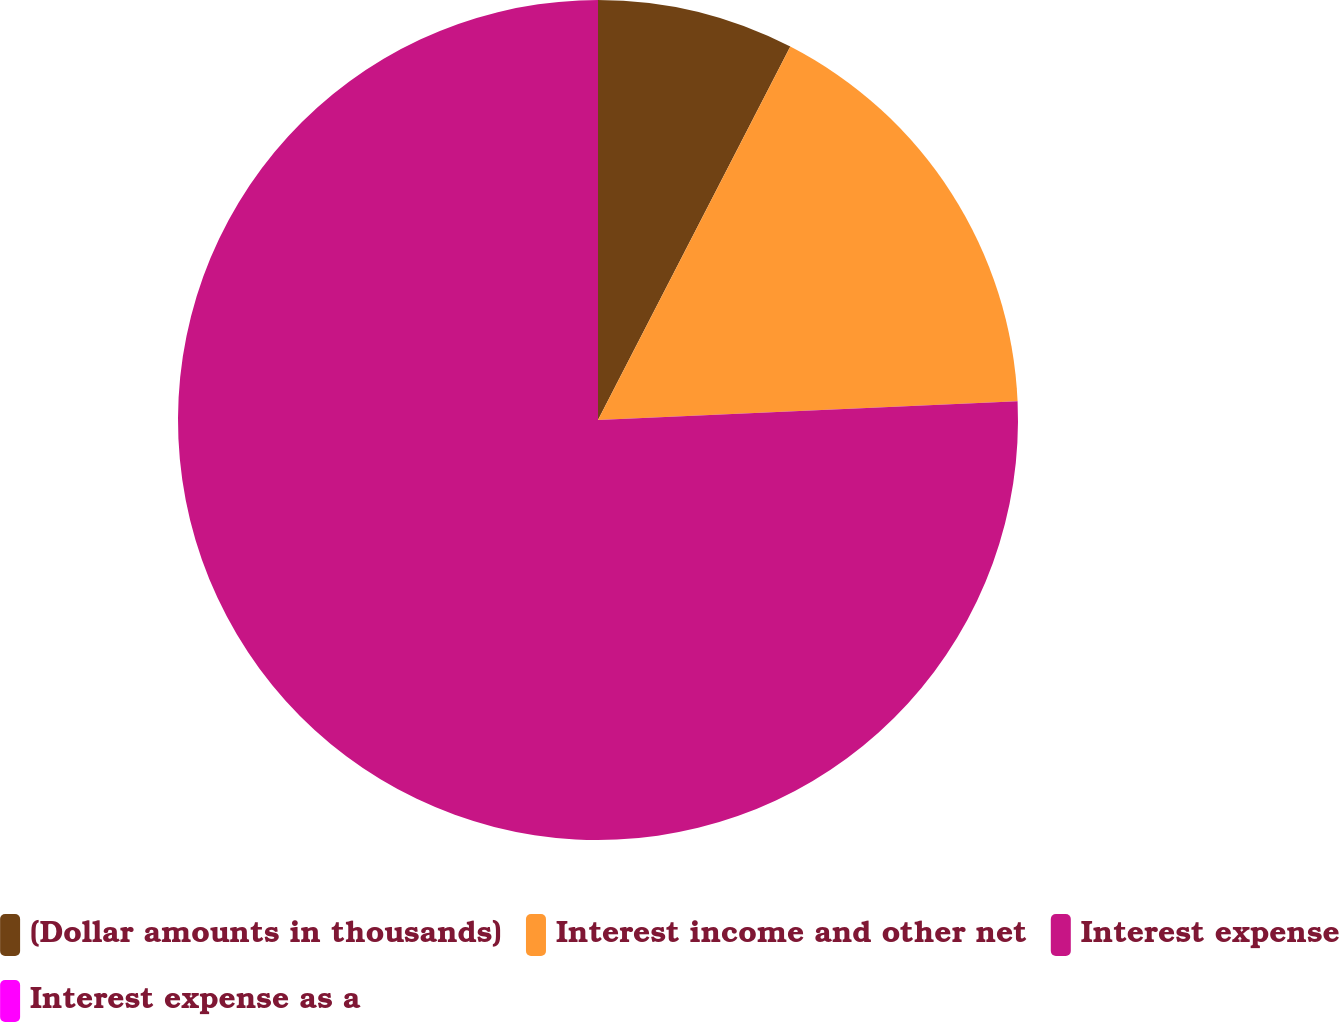Convert chart. <chart><loc_0><loc_0><loc_500><loc_500><pie_chart><fcel>(Dollar amounts in thousands)<fcel>Interest income and other net<fcel>Interest expense<fcel>Interest expense as a<nl><fcel>7.57%<fcel>16.72%<fcel>75.71%<fcel>0.0%<nl></chart> 